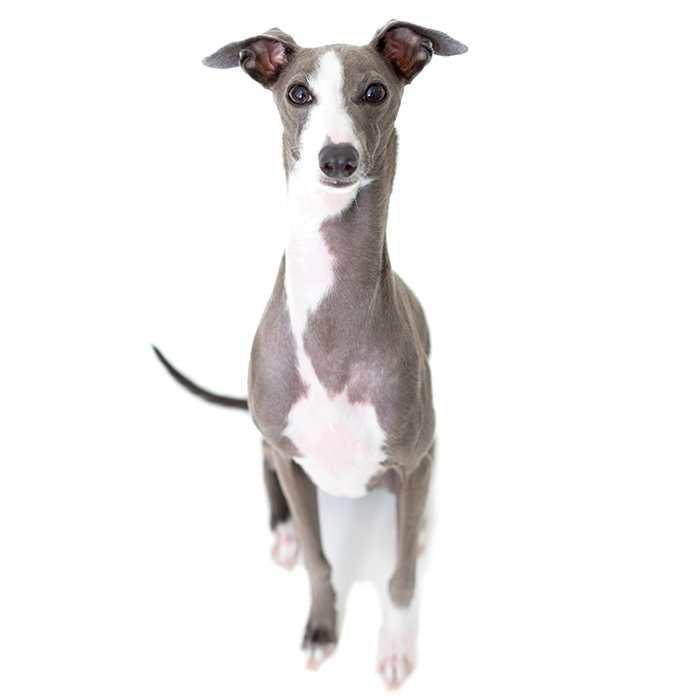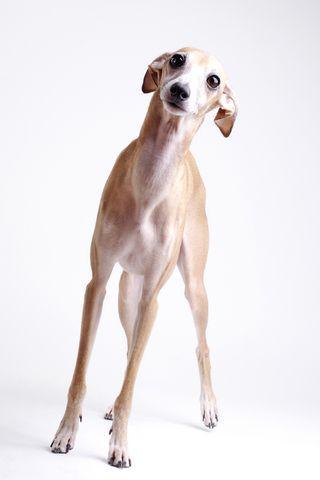The first image is the image on the left, the second image is the image on the right. Examine the images to the left and right. Is the description "Exactly one of the dogs is standing, and it is posed on green grass with body in profile." accurate? Answer yes or no. No. The first image is the image on the left, the second image is the image on the right. Assess this claim about the two images: "There is a dog with a solid gray face in one of the images.". Correct or not? Answer yes or no. No. 